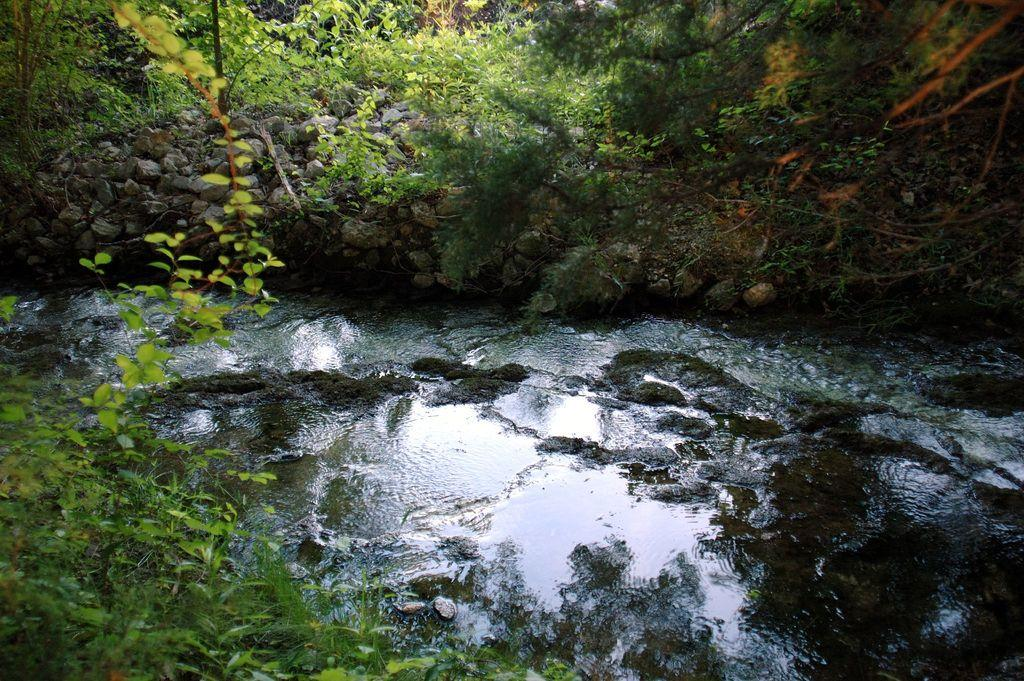What can be seen in the foreground of the image? There is greenery in the foreground of the image. What is happening in the middle of the image? Water is flowing in the middle of the image. What is visible at the top of the image? There is greenery and stones present at the top of the image. What language is spoken by the grandmother in the image? There is no grandmother present in the image, so it is not possible to determine what language she might speak. What type of bread can be seen in the image? There is no bread present in the image. 